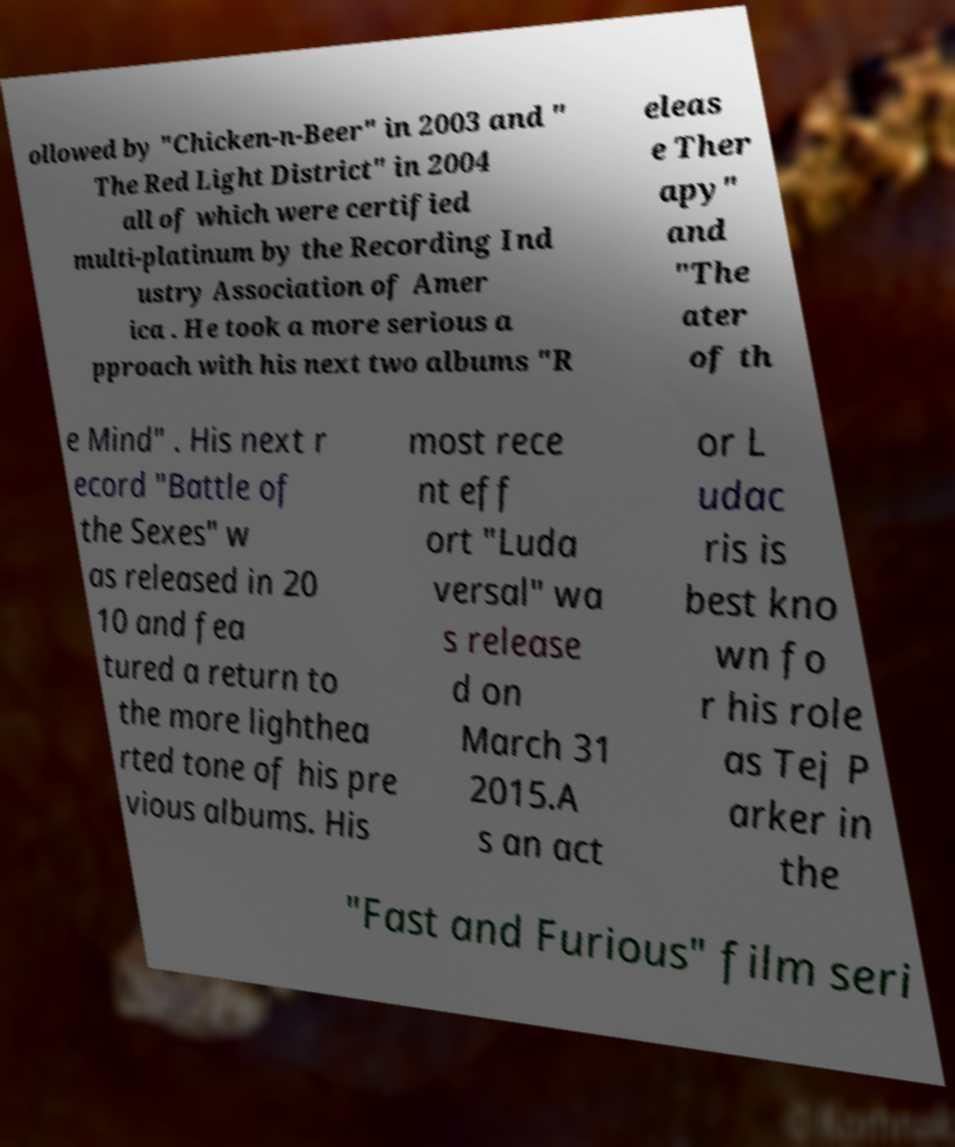What messages or text are displayed in this image? I need them in a readable, typed format. ollowed by "Chicken-n-Beer" in 2003 and " The Red Light District" in 2004 all of which were certified multi-platinum by the Recording Ind ustry Association of Amer ica . He took a more serious a pproach with his next two albums "R eleas e Ther apy" and "The ater of th e Mind" . His next r ecord "Battle of the Sexes" w as released in 20 10 and fea tured a return to the more lighthea rted tone of his pre vious albums. His most rece nt eff ort "Luda versal" wa s release d on March 31 2015.A s an act or L udac ris is best kno wn fo r his role as Tej P arker in the "Fast and Furious" film seri 